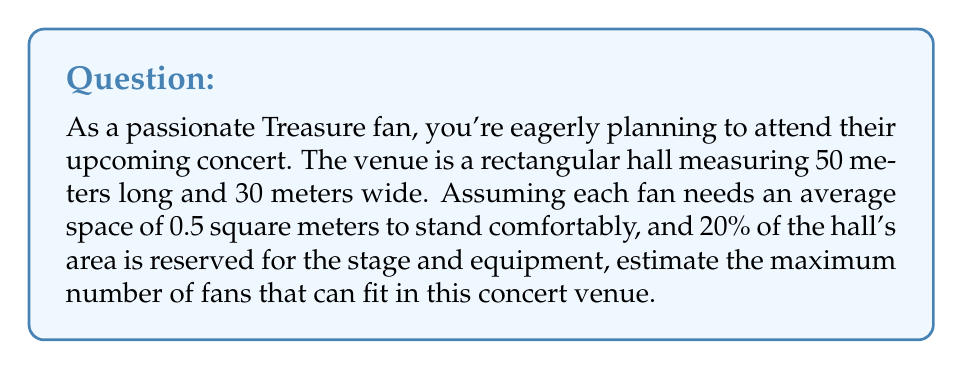Can you solve this math problem? Let's approach this problem step-by-step:

1. Calculate the total area of the hall:
   $$ A_{total} = 50 \text{ m} \times 30 \text{ m} = 1500 \text{ m}^2 $$

2. Calculate the area reserved for the stage and equipment (20% of total):
   $$ A_{reserved} = 20\% \times 1500 \text{ m}^2 = 0.2 \times 1500 \text{ m}^2 = 300 \text{ m}^2 $$

3. Calculate the available area for fans:
   $$ A_{available} = A_{total} - A_{reserved} = 1500 \text{ m}^2 - 300 \text{ m}^2 = 1200 \text{ m}^2 $$

4. Calculate the number of fans that can fit in the available area:
   $$ N_{fans} = \frac{A_{available}}{A_{per\_fan}} = \frac{1200 \text{ m}^2}{0.5 \text{ m}^2/fan} = 2400 \text{ fans} $$

Therefore, the maximum number of fans that can fit in this concert venue is 2400.
Answer: 2400 fans 